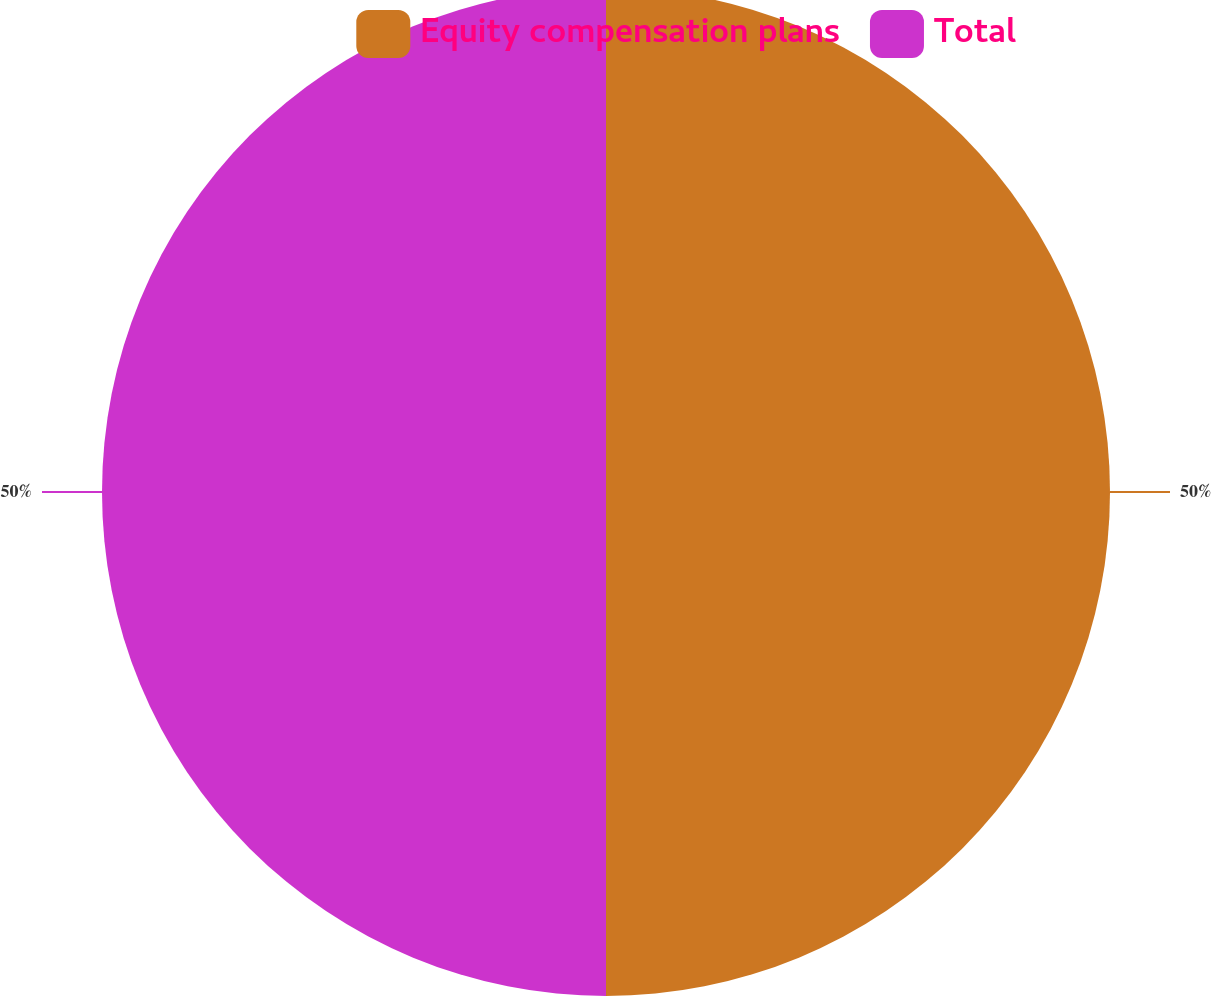Convert chart to OTSL. <chart><loc_0><loc_0><loc_500><loc_500><pie_chart><fcel>Equity compensation plans<fcel>Total<nl><fcel>50.0%<fcel>50.0%<nl></chart> 